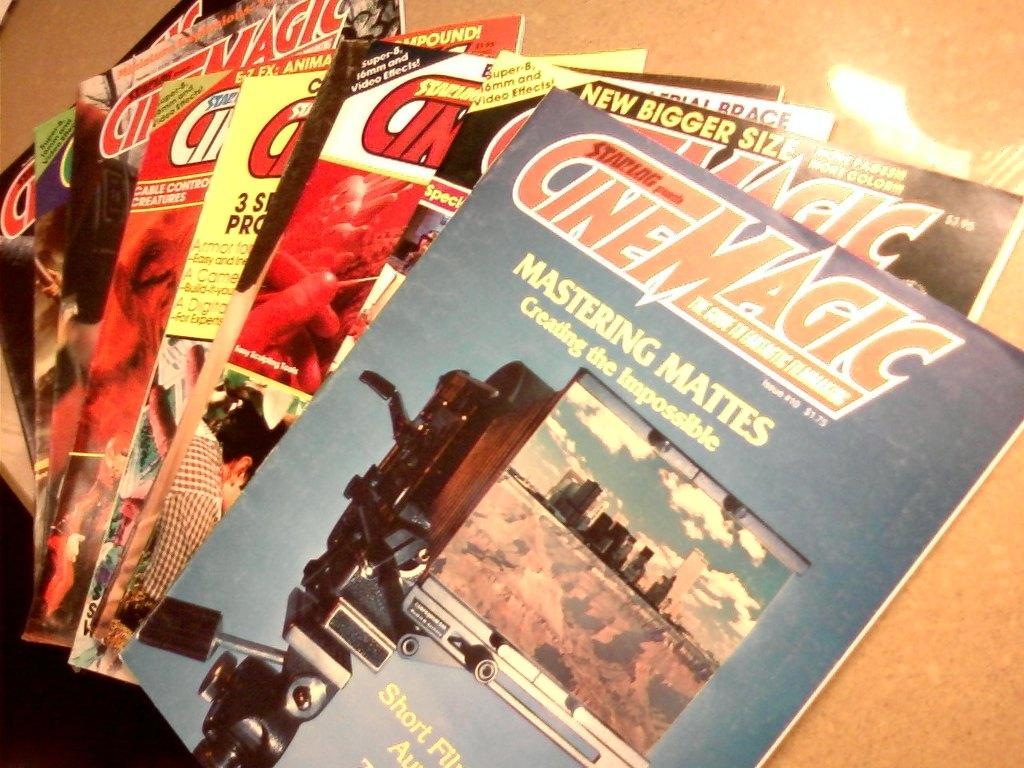<image>
Write a terse but informative summary of the picture. Magazines from the publisher Cinemagic are stacked on a table. 